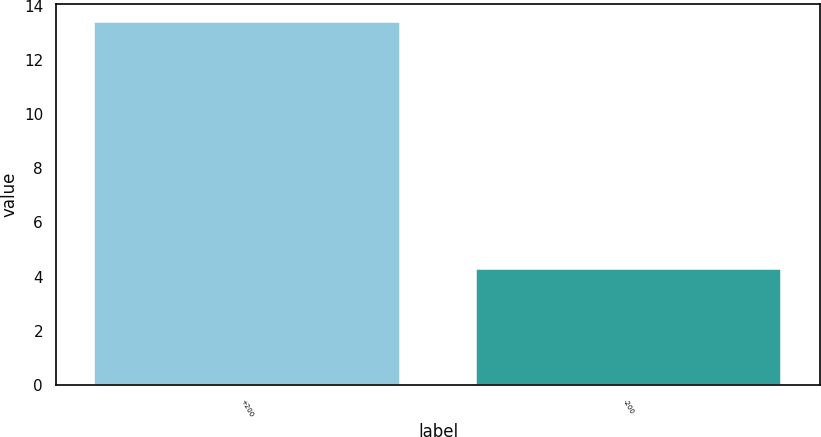Convert chart to OTSL. <chart><loc_0><loc_0><loc_500><loc_500><bar_chart><fcel>+200<fcel>-200<nl><fcel>13.4<fcel>4.3<nl></chart> 